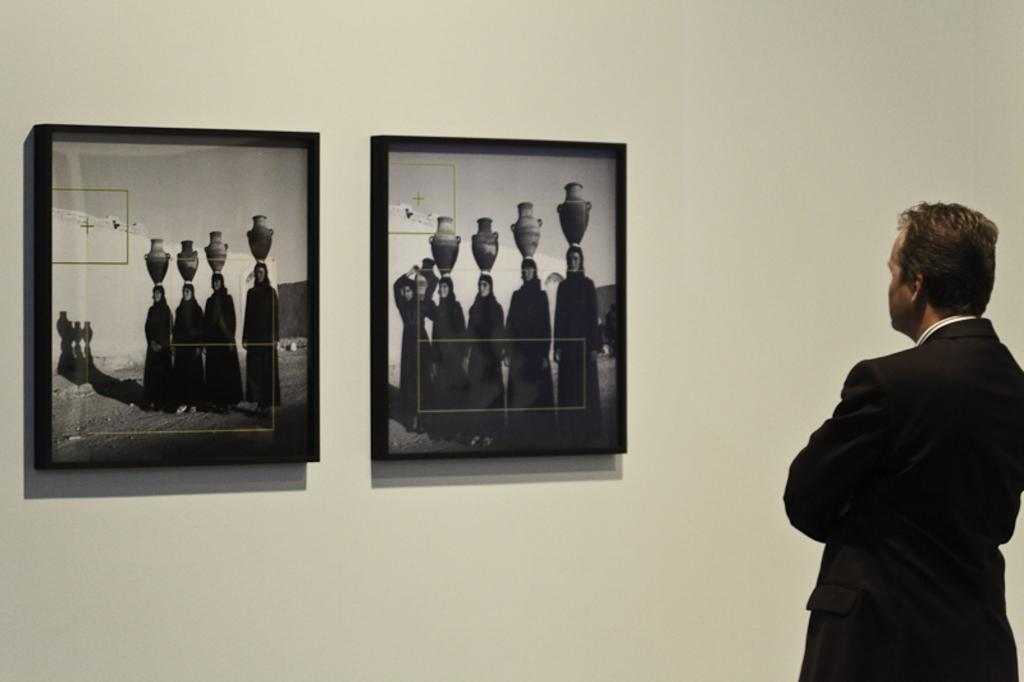What is the main subject of the image? There is a person standing in the image. How is the person positioned in relation to the viewer? The person is facing away from the viewer. What can be seen on the wall in the image? There are two frames attached to the wall in the image. What is the name of the test being conducted in the image? There is no test being conducted in the image; it features a person standing and two frames on the wall. What type of army is depicted in the image? There is no army depicted in the image. 